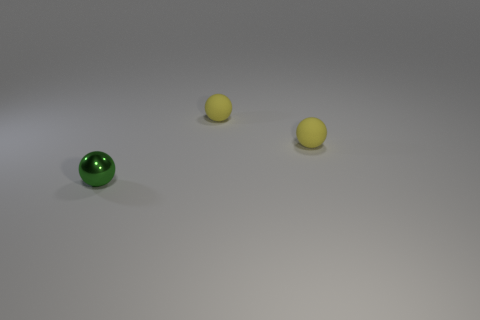What number of tiny objects are either rubber balls or green metallic things?
Provide a short and direct response. 3. What number of other things are the same color as the small shiny object?
Your response must be concise. 0. Are there fewer small yellow matte things on the left side of the tiny green shiny thing than tiny rubber things?
Your answer should be compact. Yes. How many small yellow things are made of the same material as the tiny green ball?
Your answer should be very brief. 0. There is a green shiny thing; what shape is it?
Keep it short and to the point. Sphere. Is there another object that has the same color as the metal object?
Offer a very short reply. No. What number of things are small spheres that are behind the tiny shiny object or tiny green things?
Offer a terse response. 3. Is there anything else that has the same size as the shiny object?
Offer a very short reply. Yes. Are there more big blue metallic objects than small shiny balls?
Your answer should be compact. No. Are there fewer green spheres than yellow balls?
Provide a succinct answer. Yes. 